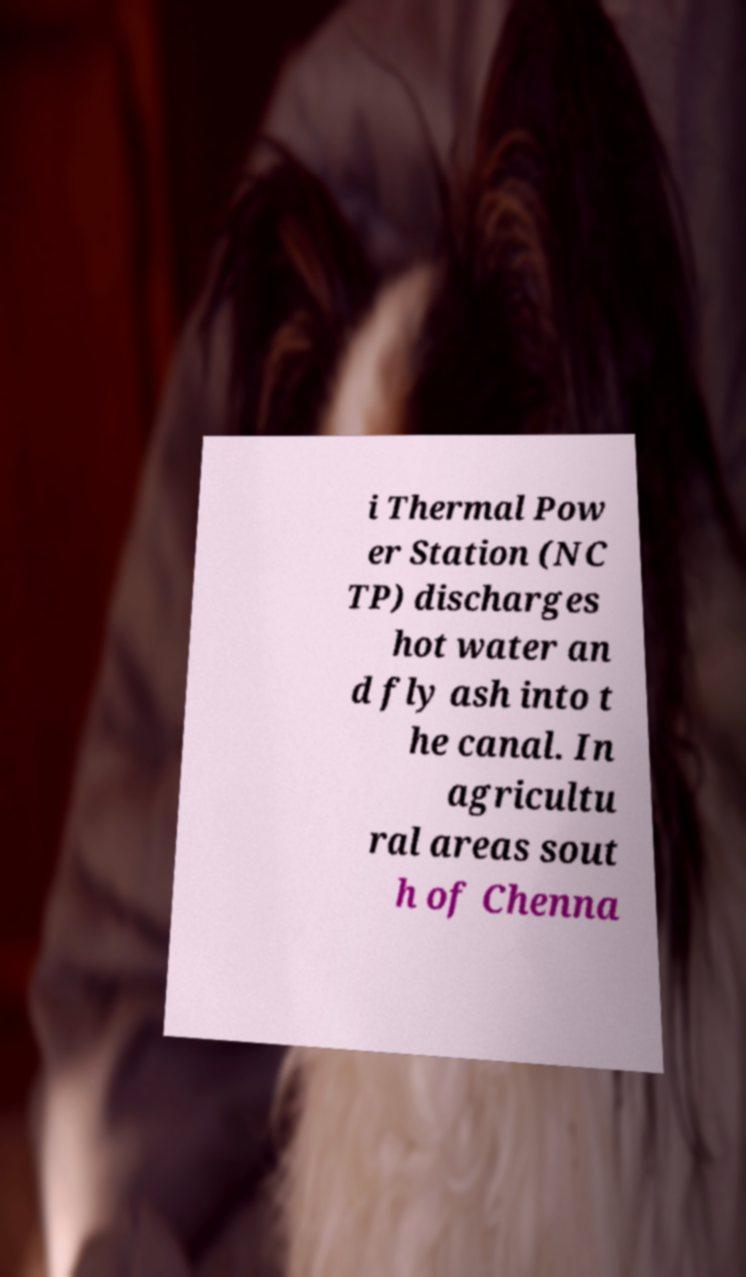What messages or text are displayed in this image? I need them in a readable, typed format. i Thermal Pow er Station (NC TP) discharges hot water an d fly ash into t he canal. In agricultu ral areas sout h of Chenna 